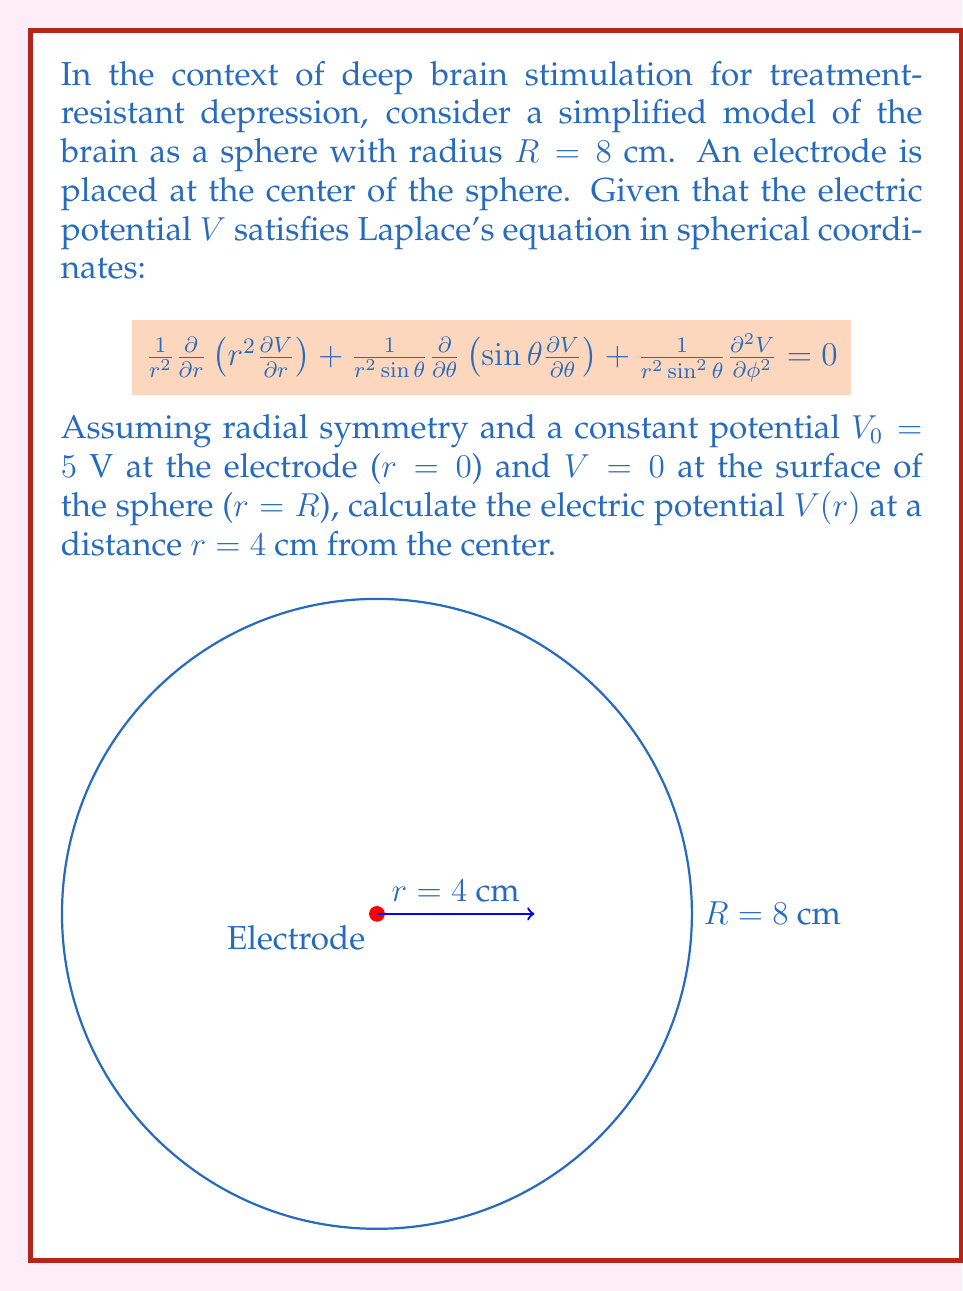Provide a solution to this math problem. To solve this problem, we'll follow these steps:

1) Given the radial symmetry, the potential $V$ depends only on $r$. Thus, Laplace's equation simplifies to:

   $$\frac{1}{r^2}\frac{d}{dr}\left(r^2\frac{dV}{dr}\right) = 0$$

2) Integrating once:

   $$r^2\frac{dV}{dr} = C_1$$

3) Integrating again:

   $$V(r) = -\frac{C_1}{r} + C_2$$

4) Apply the boundary conditions:
   At $r = 0$, $V = V_0 = 5$ V
   At $r = R = 8$ cm, $V = 0$

5) From the first condition:
   $C_2 = 5$

6) From the second condition:
   $0 = -\frac{C_1}{8} + 5$
   $C_1 = 40$

7) Therefore, the general solution is:

   $$V(r) = 5 - \frac{40}{r}$$

8) To find $V$ at $r = 4$ cm, substitute:

   $$V(4) = 5 - \frac{40}{4} = 5 - 10 = -5$$

Thus, the electric potential at $r = 4$ cm is -5 V.
Answer: $-5$ V 